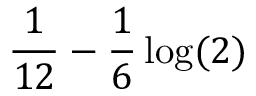Convert formula to latex. <formula><loc_0><loc_0><loc_500><loc_500>\frac { 1 } 1 2 } - \frac { 1 } { 6 } \log ( 2 )</formula> 